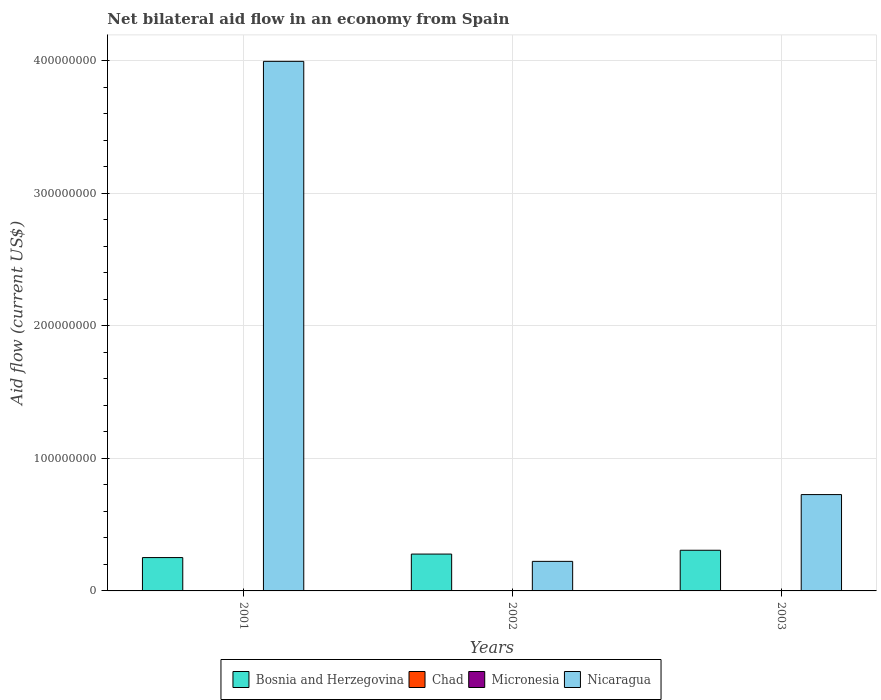How many groups of bars are there?
Your answer should be very brief. 3. Are the number of bars on each tick of the X-axis equal?
Keep it short and to the point. No. How many bars are there on the 2nd tick from the right?
Provide a short and direct response. 3. What is the label of the 2nd group of bars from the left?
Offer a terse response. 2002. In how many cases, is the number of bars for a given year not equal to the number of legend labels?
Keep it short and to the point. 2. What is the net bilateral aid flow in Nicaragua in 2001?
Ensure brevity in your answer.  3.99e+08. Across all years, what is the minimum net bilateral aid flow in Micronesia?
Your response must be concise. 4.00e+04. What is the total net bilateral aid flow in Chad in the graph?
Offer a very short reply. 3.00e+04. What is the difference between the net bilateral aid flow in Nicaragua in 2002 and that in 2003?
Your response must be concise. -5.04e+07. What is the difference between the net bilateral aid flow in Nicaragua in 2003 and the net bilateral aid flow in Bosnia and Herzegovina in 2002?
Keep it short and to the point. 4.49e+07. What is the average net bilateral aid flow in Bosnia and Herzegovina per year?
Ensure brevity in your answer.  2.79e+07. In the year 2001, what is the difference between the net bilateral aid flow in Chad and net bilateral aid flow in Nicaragua?
Your response must be concise. -3.99e+08. In how many years, is the net bilateral aid flow in Bosnia and Herzegovina greater than 220000000 US$?
Give a very brief answer. 0. What is the ratio of the net bilateral aid flow in Nicaragua in 2001 to that in 2002?
Your answer should be very brief. 17.92. What is the difference between the highest and the second highest net bilateral aid flow in Micronesia?
Offer a terse response. 5.00e+04. What is the difference between the highest and the lowest net bilateral aid flow in Nicaragua?
Make the answer very short. 3.77e+08. In how many years, is the net bilateral aid flow in Bosnia and Herzegovina greater than the average net bilateral aid flow in Bosnia and Herzegovina taken over all years?
Keep it short and to the point. 1. Is it the case that in every year, the sum of the net bilateral aid flow in Bosnia and Herzegovina and net bilateral aid flow in Nicaragua is greater than the net bilateral aid flow in Chad?
Ensure brevity in your answer.  Yes. How many bars are there?
Provide a succinct answer. 10. Are all the bars in the graph horizontal?
Offer a terse response. No. How many years are there in the graph?
Your answer should be very brief. 3. Are the values on the major ticks of Y-axis written in scientific E-notation?
Ensure brevity in your answer.  No. How many legend labels are there?
Provide a succinct answer. 4. How are the legend labels stacked?
Make the answer very short. Horizontal. What is the title of the graph?
Your answer should be very brief. Net bilateral aid flow in an economy from Spain. Does "Jordan" appear as one of the legend labels in the graph?
Provide a succinct answer. No. What is the Aid flow (current US$) of Bosnia and Herzegovina in 2001?
Make the answer very short. 2.52e+07. What is the Aid flow (current US$) in Chad in 2001?
Your answer should be very brief. 3.00e+04. What is the Aid flow (current US$) of Micronesia in 2001?
Ensure brevity in your answer.  4.00e+04. What is the Aid flow (current US$) of Nicaragua in 2001?
Your answer should be very brief. 3.99e+08. What is the Aid flow (current US$) in Bosnia and Herzegovina in 2002?
Offer a very short reply. 2.78e+07. What is the Aid flow (current US$) in Chad in 2002?
Offer a very short reply. 0. What is the Aid flow (current US$) in Micronesia in 2002?
Keep it short and to the point. 1.50e+05. What is the Aid flow (current US$) of Nicaragua in 2002?
Provide a succinct answer. 2.23e+07. What is the Aid flow (current US$) of Bosnia and Herzegovina in 2003?
Keep it short and to the point. 3.07e+07. What is the Aid flow (current US$) of Nicaragua in 2003?
Your response must be concise. 7.27e+07. Across all years, what is the maximum Aid flow (current US$) of Bosnia and Herzegovina?
Keep it short and to the point. 3.07e+07. Across all years, what is the maximum Aid flow (current US$) of Micronesia?
Your answer should be compact. 1.50e+05. Across all years, what is the maximum Aid flow (current US$) of Nicaragua?
Your response must be concise. 3.99e+08. Across all years, what is the minimum Aid flow (current US$) in Bosnia and Herzegovina?
Provide a succinct answer. 2.52e+07. Across all years, what is the minimum Aid flow (current US$) in Micronesia?
Keep it short and to the point. 4.00e+04. Across all years, what is the minimum Aid flow (current US$) in Nicaragua?
Give a very brief answer. 2.23e+07. What is the total Aid flow (current US$) in Bosnia and Herzegovina in the graph?
Your answer should be very brief. 8.36e+07. What is the total Aid flow (current US$) in Nicaragua in the graph?
Ensure brevity in your answer.  4.94e+08. What is the difference between the Aid flow (current US$) of Bosnia and Herzegovina in 2001 and that in 2002?
Make the answer very short. -2.64e+06. What is the difference between the Aid flow (current US$) in Micronesia in 2001 and that in 2002?
Ensure brevity in your answer.  -1.10e+05. What is the difference between the Aid flow (current US$) in Nicaragua in 2001 and that in 2002?
Your answer should be compact. 3.77e+08. What is the difference between the Aid flow (current US$) of Bosnia and Herzegovina in 2001 and that in 2003?
Provide a short and direct response. -5.51e+06. What is the difference between the Aid flow (current US$) in Micronesia in 2001 and that in 2003?
Your response must be concise. -6.00e+04. What is the difference between the Aid flow (current US$) of Nicaragua in 2001 and that in 2003?
Give a very brief answer. 3.27e+08. What is the difference between the Aid flow (current US$) in Bosnia and Herzegovina in 2002 and that in 2003?
Provide a short and direct response. -2.87e+06. What is the difference between the Aid flow (current US$) of Micronesia in 2002 and that in 2003?
Offer a very short reply. 5.00e+04. What is the difference between the Aid flow (current US$) in Nicaragua in 2002 and that in 2003?
Make the answer very short. -5.04e+07. What is the difference between the Aid flow (current US$) of Bosnia and Herzegovina in 2001 and the Aid flow (current US$) of Micronesia in 2002?
Provide a succinct answer. 2.50e+07. What is the difference between the Aid flow (current US$) of Bosnia and Herzegovina in 2001 and the Aid flow (current US$) of Nicaragua in 2002?
Offer a very short reply. 2.87e+06. What is the difference between the Aid flow (current US$) in Chad in 2001 and the Aid flow (current US$) in Micronesia in 2002?
Keep it short and to the point. -1.20e+05. What is the difference between the Aid flow (current US$) in Chad in 2001 and the Aid flow (current US$) in Nicaragua in 2002?
Keep it short and to the point. -2.23e+07. What is the difference between the Aid flow (current US$) of Micronesia in 2001 and the Aid flow (current US$) of Nicaragua in 2002?
Your response must be concise. -2.22e+07. What is the difference between the Aid flow (current US$) of Bosnia and Herzegovina in 2001 and the Aid flow (current US$) of Micronesia in 2003?
Your answer should be very brief. 2.51e+07. What is the difference between the Aid flow (current US$) of Bosnia and Herzegovina in 2001 and the Aid flow (current US$) of Nicaragua in 2003?
Provide a short and direct response. -4.75e+07. What is the difference between the Aid flow (current US$) of Chad in 2001 and the Aid flow (current US$) of Micronesia in 2003?
Offer a terse response. -7.00e+04. What is the difference between the Aid flow (current US$) in Chad in 2001 and the Aid flow (current US$) in Nicaragua in 2003?
Offer a very short reply. -7.26e+07. What is the difference between the Aid flow (current US$) in Micronesia in 2001 and the Aid flow (current US$) in Nicaragua in 2003?
Your answer should be very brief. -7.26e+07. What is the difference between the Aid flow (current US$) of Bosnia and Herzegovina in 2002 and the Aid flow (current US$) of Micronesia in 2003?
Offer a very short reply. 2.77e+07. What is the difference between the Aid flow (current US$) of Bosnia and Herzegovina in 2002 and the Aid flow (current US$) of Nicaragua in 2003?
Offer a very short reply. -4.49e+07. What is the difference between the Aid flow (current US$) in Micronesia in 2002 and the Aid flow (current US$) in Nicaragua in 2003?
Offer a very short reply. -7.25e+07. What is the average Aid flow (current US$) of Bosnia and Herzegovina per year?
Give a very brief answer. 2.79e+07. What is the average Aid flow (current US$) of Micronesia per year?
Ensure brevity in your answer.  9.67e+04. What is the average Aid flow (current US$) of Nicaragua per year?
Your answer should be compact. 1.65e+08. In the year 2001, what is the difference between the Aid flow (current US$) in Bosnia and Herzegovina and Aid flow (current US$) in Chad?
Provide a succinct answer. 2.51e+07. In the year 2001, what is the difference between the Aid flow (current US$) in Bosnia and Herzegovina and Aid flow (current US$) in Micronesia?
Keep it short and to the point. 2.51e+07. In the year 2001, what is the difference between the Aid flow (current US$) in Bosnia and Herzegovina and Aid flow (current US$) in Nicaragua?
Give a very brief answer. -3.74e+08. In the year 2001, what is the difference between the Aid flow (current US$) in Chad and Aid flow (current US$) in Nicaragua?
Make the answer very short. -3.99e+08. In the year 2001, what is the difference between the Aid flow (current US$) of Micronesia and Aid flow (current US$) of Nicaragua?
Your answer should be compact. -3.99e+08. In the year 2002, what is the difference between the Aid flow (current US$) of Bosnia and Herzegovina and Aid flow (current US$) of Micronesia?
Provide a succinct answer. 2.76e+07. In the year 2002, what is the difference between the Aid flow (current US$) in Bosnia and Herzegovina and Aid flow (current US$) in Nicaragua?
Your answer should be very brief. 5.51e+06. In the year 2002, what is the difference between the Aid flow (current US$) of Micronesia and Aid flow (current US$) of Nicaragua?
Make the answer very short. -2.21e+07. In the year 2003, what is the difference between the Aid flow (current US$) in Bosnia and Herzegovina and Aid flow (current US$) in Micronesia?
Your response must be concise. 3.06e+07. In the year 2003, what is the difference between the Aid flow (current US$) in Bosnia and Herzegovina and Aid flow (current US$) in Nicaragua?
Make the answer very short. -4.20e+07. In the year 2003, what is the difference between the Aid flow (current US$) of Micronesia and Aid flow (current US$) of Nicaragua?
Provide a succinct answer. -7.26e+07. What is the ratio of the Aid flow (current US$) of Bosnia and Herzegovina in 2001 to that in 2002?
Your answer should be very brief. 0.91. What is the ratio of the Aid flow (current US$) of Micronesia in 2001 to that in 2002?
Provide a short and direct response. 0.27. What is the ratio of the Aid flow (current US$) in Nicaragua in 2001 to that in 2002?
Provide a short and direct response. 17.92. What is the ratio of the Aid flow (current US$) in Bosnia and Herzegovina in 2001 to that in 2003?
Make the answer very short. 0.82. What is the ratio of the Aid flow (current US$) in Micronesia in 2001 to that in 2003?
Offer a very short reply. 0.4. What is the ratio of the Aid flow (current US$) of Nicaragua in 2001 to that in 2003?
Make the answer very short. 5.5. What is the ratio of the Aid flow (current US$) of Bosnia and Herzegovina in 2002 to that in 2003?
Your response must be concise. 0.91. What is the ratio of the Aid flow (current US$) of Nicaragua in 2002 to that in 2003?
Offer a very short reply. 0.31. What is the difference between the highest and the second highest Aid flow (current US$) in Bosnia and Herzegovina?
Provide a short and direct response. 2.87e+06. What is the difference between the highest and the second highest Aid flow (current US$) in Nicaragua?
Provide a succinct answer. 3.27e+08. What is the difference between the highest and the lowest Aid flow (current US$) in Bosnia and Herzegovina?
Provide a short and direct response. 5.51e+06. What is the difference between the highest and the lowest Aid flow (current US$) of Chad?
Keep it short and to the point. 3.00e+04. What is the difference between the highest and the lowest Aid flow (current US$) in Micronesia?
Your answer should be very brief. 1.10e+05. What is the difference between the highest and the lowest Aid flow (current US$) in Nicaragua?
Offer a very short reply. 3.77e+08. 